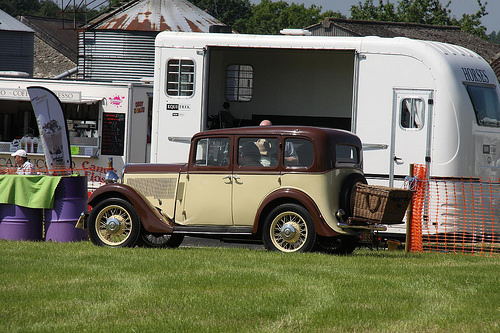<image>
Can you confirm if the food truck is next to the trailer? Yes. The food truck is positioned adjacent to the trailer, located nearby in the same general area. 